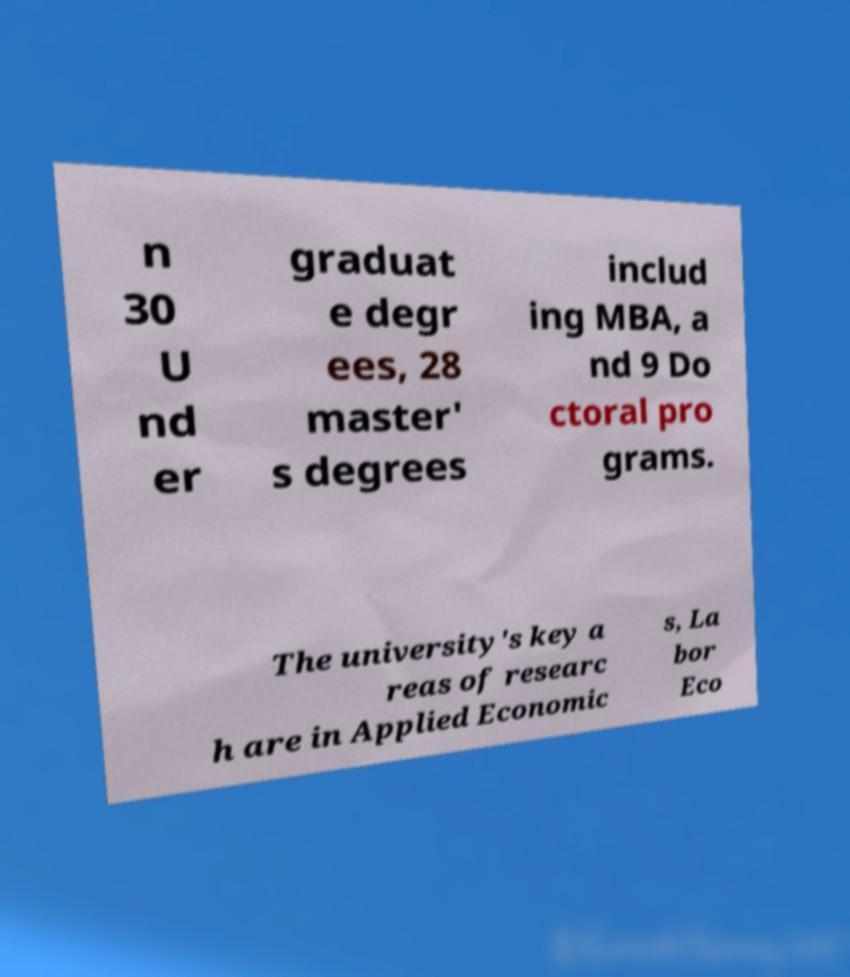Could you assist in decoding the text presented in this image and type it out clearly? n 30 U nd er graduat e degr ees, 28 master' s degrees includ ing MBA, a nd 9 Do ctoral pro grams. The university's key a reas of researc h are in Applied Economic s, La bor Eco 